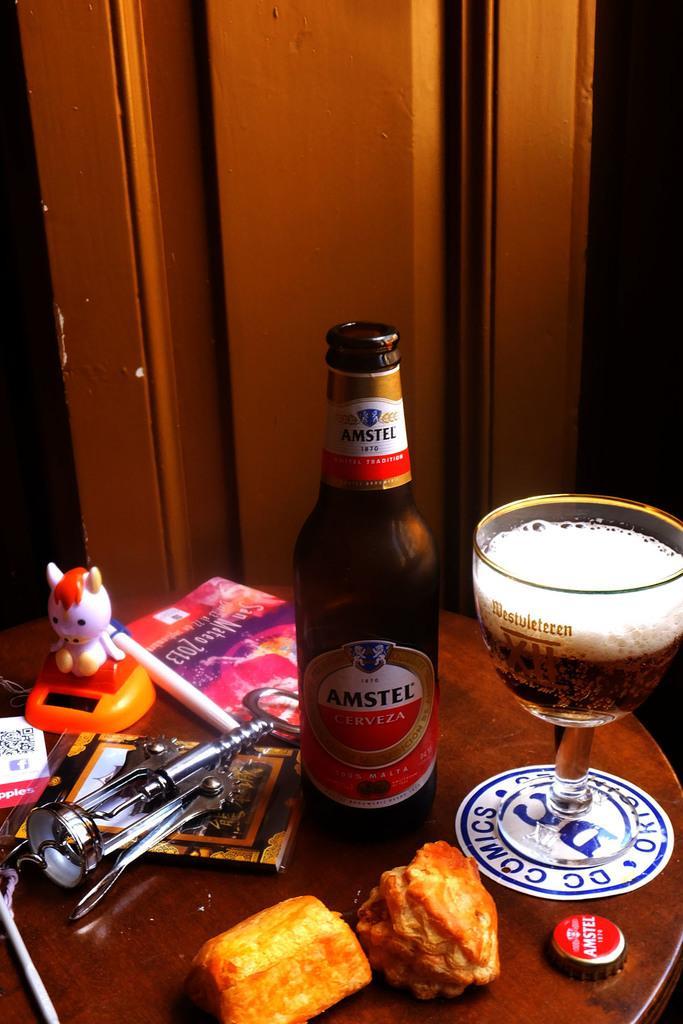How would you summarize this image in a sentence or two? In the picture there is a table and on the table there is a bottle, a glass with some drink, snacks, a book, marker and some other things are kept. Behind the table there is a wooden background. 